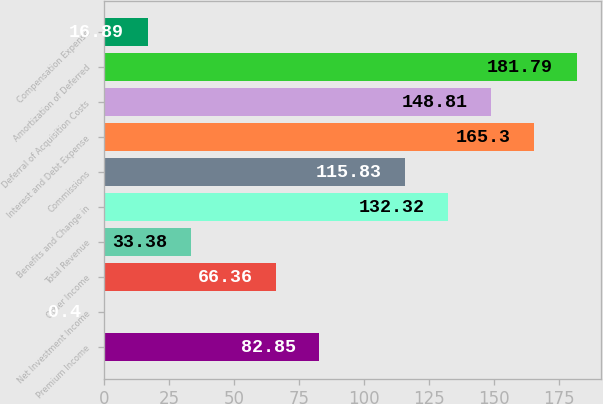Convert chart. <chart><loc_0><loc_0><loc_500><loc_500><bar_chart><fcel>Premium Income<fcel>Net Investment Income<fcel>Other Income<fcel>Total Revenue<fcel>Benefits and Change in<fcel>Commissions<fcel>Interest and Debt Expense<fcel>Deferral of Acquisition Costs<fcel>Amortization of Deferred<fcel>Compensation Expense<nl><fcel>82.85<fcel>0.4<fcel>66.36<fcel>33.38<fcel>132.32<fcel>115.83<fcel>165.3<fcel>148.81<fcel>181.79<fcel>16.89<nl></chart> 